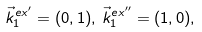<formula> <loc_0><loc_0><loc_500><loc_500>\vec { k } ^ { e x ^ { \prime } } _ { 1 } = ( 0 , 1 ) , \, \vec { k } ^ { e x ^ { \prime \prime } } _ { 1 } = ( 1 , 0 ) ,</formula> 